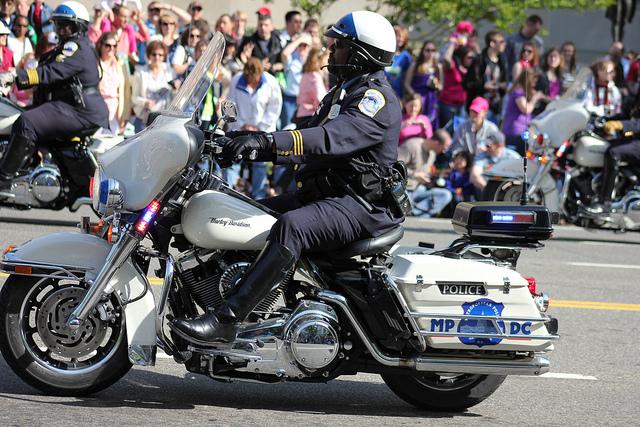Is this man working?
Keep it brief. Yes. What are the women taking a picture of?
Short answer required. Police. Is this a police officer?
Quick response, please. Yes. What common interest do these people share?
Write a very short answer. Police. What is the brand of bike?
Be succinct. Harley davidson. Is this a biker social event?
Be succinct. No. 